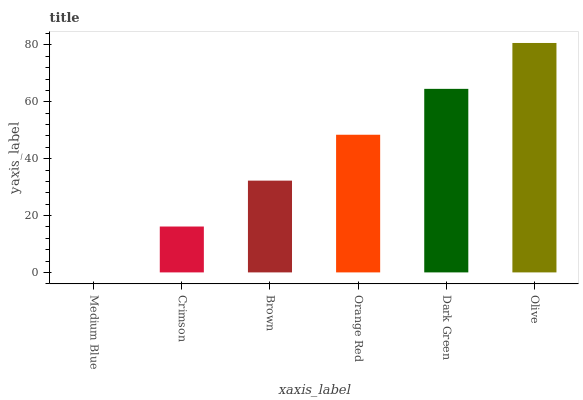Is Crimson the minimum?
Answer yes or no. No. Is Crimson the maximum?
Answer yes or no. No. Is Crimson greater than Medium Blue?
Answer yes or no. Yes. Is Medium Blue less than Crimson?
Answer yes or no. Yes. Is Medium Blue greater than Crimson?
Answer yes or no. No. Is Crimson less than Medium Blue?
Answer yes or no. No. Is Orange Red the high median?
Answer yes or no. Yes. Is Brown the low median?
Answer yes or no. Yes. Is Brown the high median?
Answer yes or no. No. Is Crimson the low median?
Answer yes or no. No. 